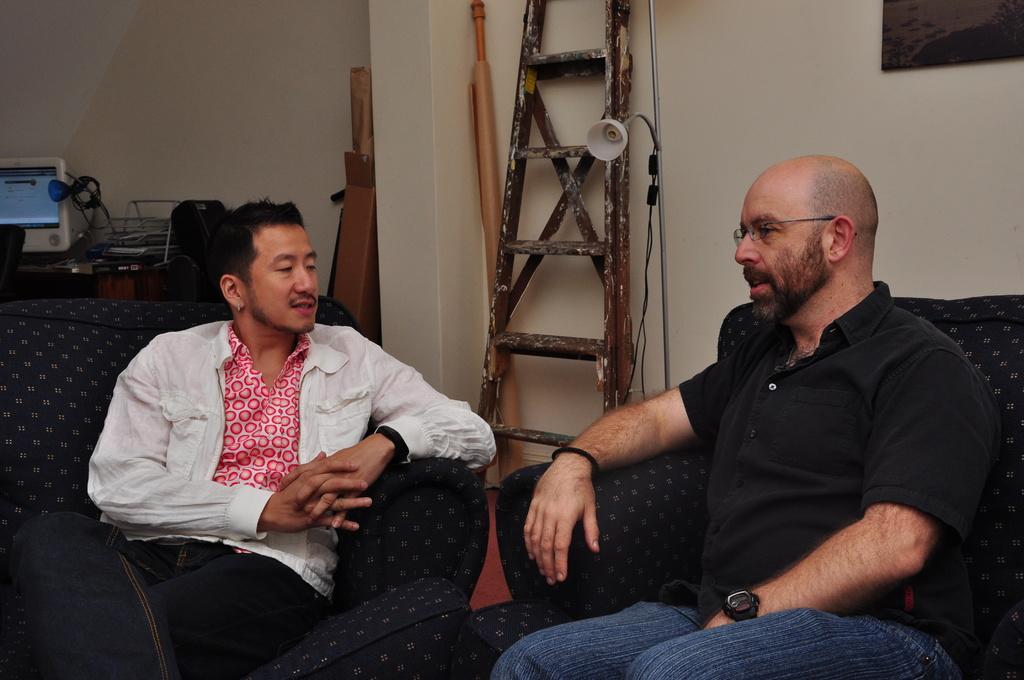How would you summarize this image in a sentence or two? These two people are sitting on the couch. On this table there is a monitor, cable and things. Beside this ladder there is a lamp. Picture is on the wall.  